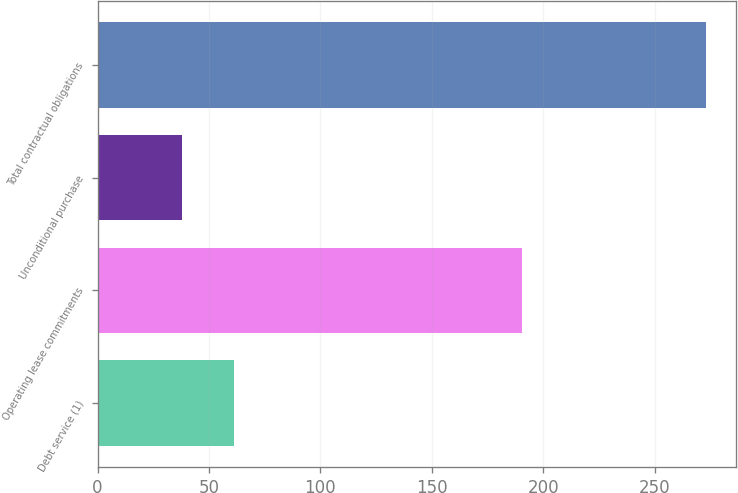<chart> <loc_0><loc_0><loc_500><loc_500><bar_chart><fcel>Debt service (1)<fcel>Operating lease commitments<fcel>Unconditional purchase<fcel>Total contractual obligations<nl><fcel>61.32<fcel>190.6<fcel>37.8<fcel>273<nl></chart> 